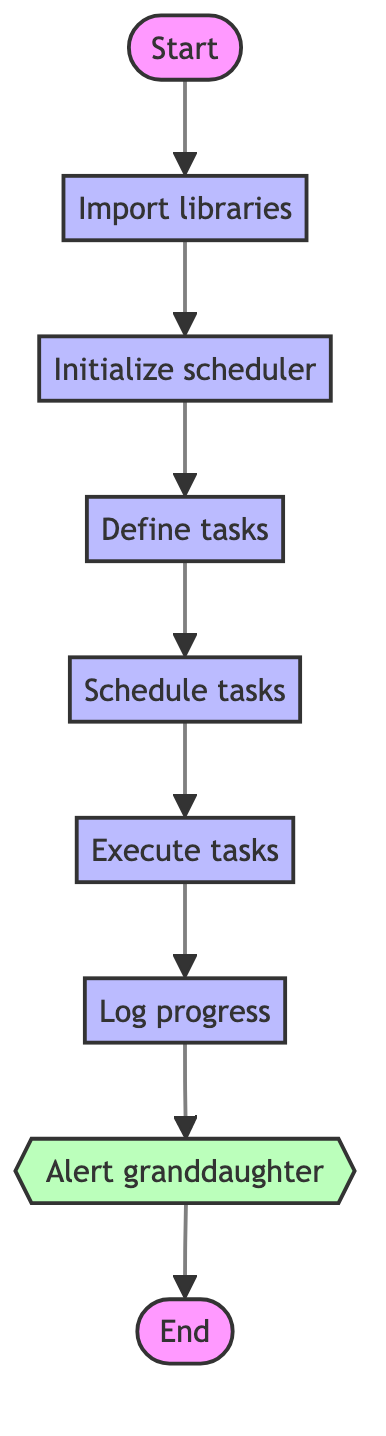What is the first process in the flowchart? The first process indicated in the flowchart is "Import libraries," which is represented by node B. This is the initial step after starting the function.
Answer: Import libraries How many processes are there in total? The diagram includes six processes: "Import libraries," "Initialize scheduler," "Define tasks," "Schedule tasks," "Execute tasks," and "Log progress." Counting these nodes gives a total of six processes.
Answer: Six What is the last step before sending an alert? The last step before sending an alert is "Log progress," located at node G. This step occurs just before the alert subprocess is triggered.
Answer: Log progress What does the alert subprocess do? The alert subprocess, labeled "Alert granddaughter," is responsible for sending a notification to let her know to move to the next task, as indicated by its sub-process type designation.
Answer: Send an alert or notification What is the main purpose of this flowchart? The main purpose of the flowchart is to outline the steps involved in automating a guitar practice routine using a timer, detailing the sequential processes from start to finish.
Answer: Automating guitar practice routine Which process follows the initialization of the scheduler? The process that follows the initialization of the scheduler, represented by node C, is "Define tasks," which is node D in the flowchart. This step sets up the specific tasks to be practiced.
Answer: Define tasks What type of node is the starting point of the function? The starting point of the function is categorized as a "start" node, which is indicated by node A at the very beginning of the flowchart.
Answer: Start What indicates the end of the flowchart sequence? The end of the flowchart sequence is indicated by the "End" node, labeled as I, which marks the completion of all tasks and processes within the function.
Answer: End 